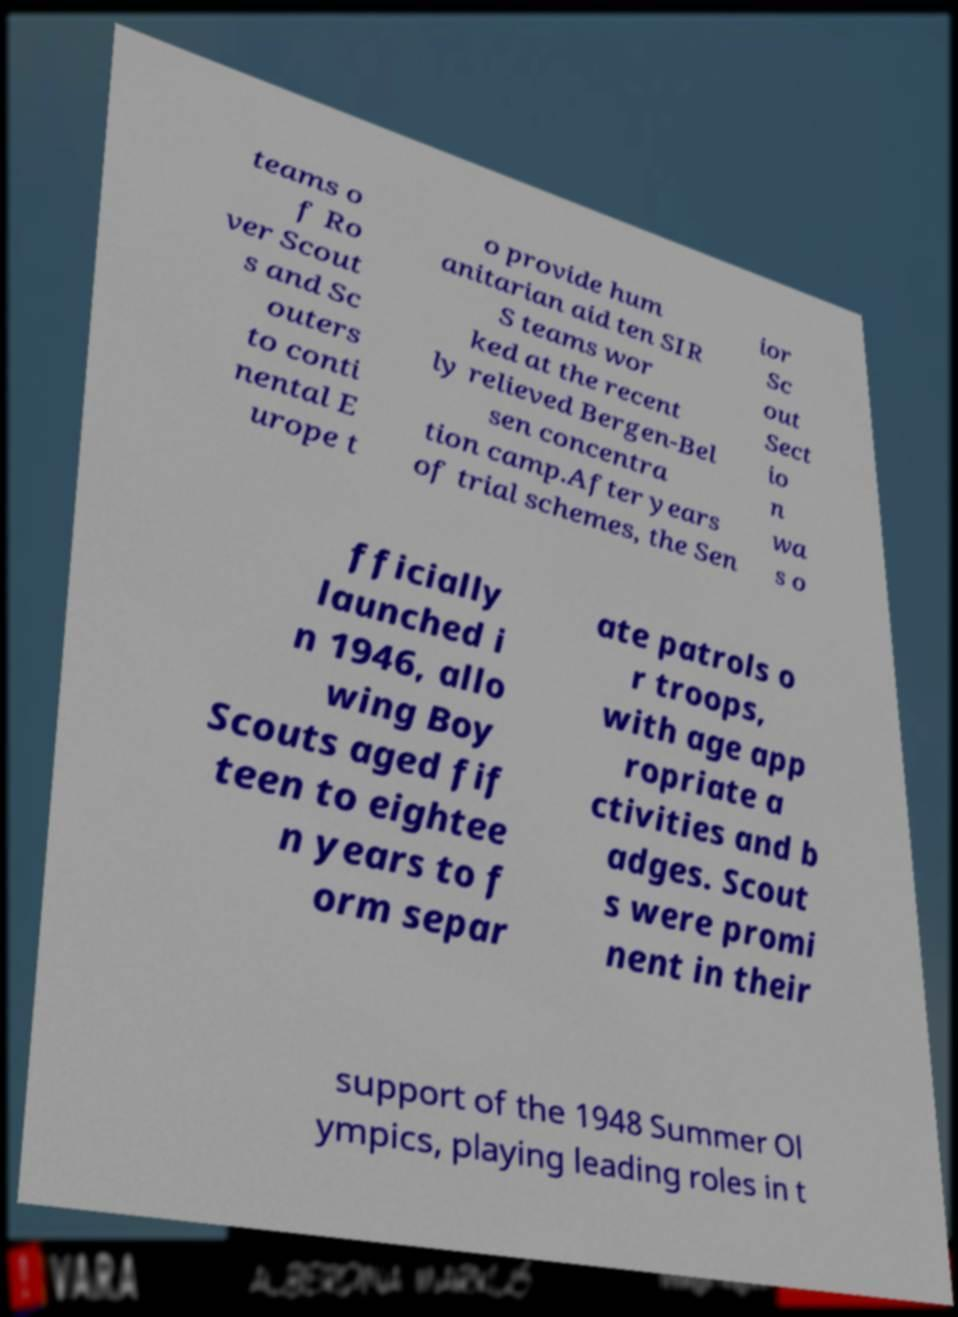Could you extract and type out the text from this image? teams o f Ro ver Scout s and Sc outers to conti nental E urope t o provide hum anitarian aid ten SIR S teams wor ked at the recent ly relieved Bergen-Bel sen concentra tion camp.After years of trial schemes, the Sen ior Sc out Sect io n wa s o fficially launched i n 1946, allo wing Boy Scouts aged fif teen to eightee n years to f orm separ ate patrols o r troops, with age app ropriate a ctivities and b adges. Scout s were promi nent in their support of the 1948 Summer Ol ympics, playing leading roles in t 